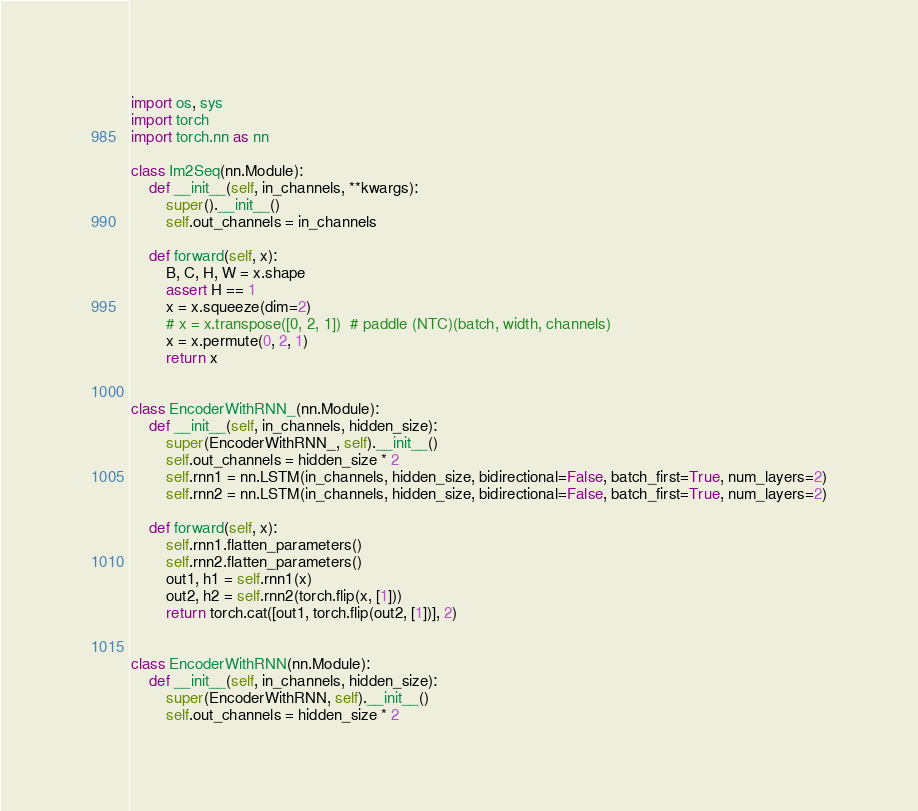<code> <loc_0><loc_0><loc_500><loc_500><_Python_>import os, sys
import torch
import torch.nn as nn

class Im2Seq(nn.Module):
    def __init__(self, in_channels, **kwargs):
        super().__init__()
        self.out_channels = in_channels

    def forward(self, x):
        B, C, H, W = x.shape
        assert H == 1
        x = x.squeeze(dim=2)
        # x = x.transpose([0, 2, 1])  # paddle (NTC)(batch, width, channels)
        x = x.permute(0, 2, 1)
        return x


class EncoderWithRNN_(nn.Module):
    def __init__(self, in_channels, hidden_size):
        super(EncoderWithRNN_, self).__init__()
        self.out_channels = hidden_size * 2
        self.rnn1 = nn.LSTM(in_channels, hidden_size, bidirectional=False, batch_first=True, num_layers=2)
        self.rnn2 = nn.LSTM(in_channels, hidden_size, bidirectional=False, batch_first=True, num_layers=2)

    def forward(self, x):
        self.rnn1.flatten_parameters()
        self.rnn2.flatten_parameters()
        out1, h1 = self.rnn1(x)
        out2, h2 = self.rnn2(torch.flip(x, [1]))
        return torch.cat([out1, torch.flip(out2, [1])], 2)


class EncoderWithRNN(nn.Module):
    def __init__(self, in_channels, hidden_size):
        super(EncoderWithRNN, self).__init__()
        self.out_channels = hidden_size * 2</code> 